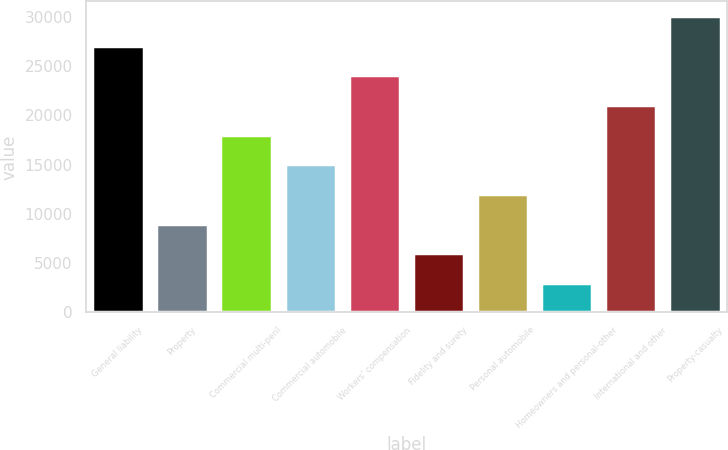<chart> <loc_0><loc_0><loc_500><loc_500><bar_chart><fcel>General liability<fcel>Property<fcel>Commercial multi-peril<fcel>Commercial automobile<fcel>Workers' compensation<fcel>Fidelity and surety<fcel>Personal automobile<fcel>Homeowners and personal-other<fcel>International and other<fcel>Property-casualty<nl><fcel>27066.7<fcel>9028.9<fcel>18047.8<fcel>15041.5<fcel>24060.4<fcel>6022.6<fcel>12035.2<fcel>3016.3<fcel>21054.1<fcel>30073<nl></chart> 